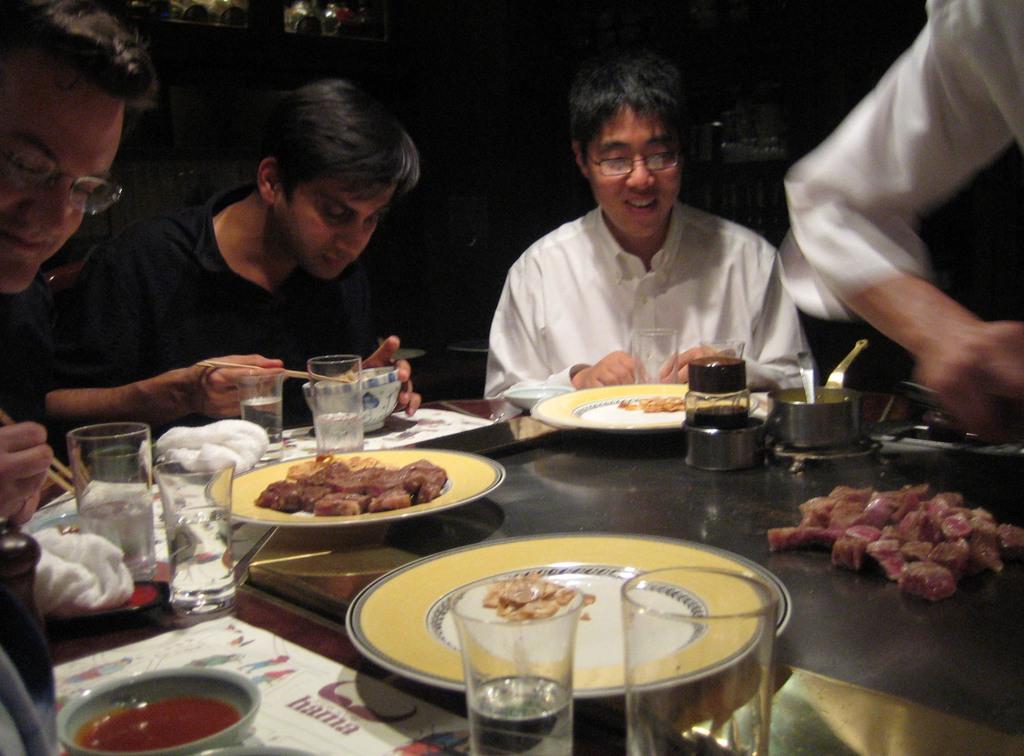Can you describe this image briefly? In the picture a group of people were having food by sitting in front of a table and on the table there are some food items and glasses and napkins were kept. 